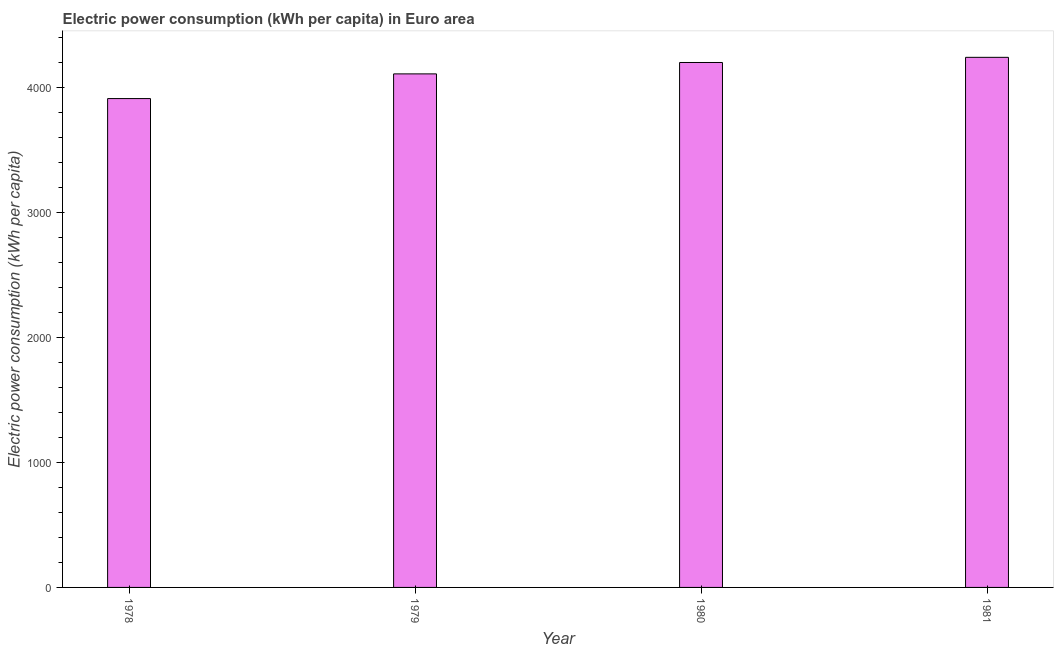Does the graph contain any zero values?
Give a very brief answer. No. Does the graph contain grids?
Give a very brief answer. No. What is the title of the graph?
Your answer should be compact. Electric power consumption (kWh per capita) in Euro area. What is the label or title of the Y-axis?
Give a very brief answer. Electric power consumption (kWh per capita). What is the electric power consumption in 1980?
Offer a very short reply. 4201.19. Across all years, what is the maximum electric power consumption?
Keep it short and to the point. 4242.56. Across all years, what is the minimum electric power consumption?
Offer a terse response. 3912.47. In which year was the electric power consumption minimum?
Make the answer very short. 1978. What is the sum of the electric power consumption?
Your answer should be compact. 1.65e+04. What is the difference between the electric power consumption in 1978 and 1981?
Offer a terse response. -330.09. What is the average electric power consumption per year?
Offer a very short reply. 4116.57. What is the median electric power consumption?
Provide a succinct answer. 4155.62. In how many years, is the electric power consumption greater than 2000 kWh per capita?
Offer a very short reply. 4. Do a majority of the years between 1978 and 1981 (inclusive) have electric power consumption greater than 800 kWh per capita?
Your answer should be very brief. Yes. Is the electric power consumption in 1978 less than that in 1980?
Give a very brief answer. Yes. What is the difference between the highest and the second highest electric power consumption?
Offer a very short reply. 41.37. What is the difference between the highest and the lowest electric power consumption?
Provide a short and direct response. 330.09. In how many years, is the electric power consumption greater than the average electric power consumption taken over all years?
Provide a short and direct response. 2. How many bars are there?
Provide a short and direct response. 4. Are all the bars in the graph horizontal?
Offer a very short reply. No. How many years are there in the graph?
Make the answer very short. 4. Are the values on the major ticks of Y-axis written in scientific E-notation?
Keep it short and to the point. No. What is the Electric power consumption (kWh per capita) of 1978?
Make the answer very short. 3912.47. What is the Electric power consumption (kWh per capita) of 1979?
Your answer should be very brief. 4110.05. What is the Electric power consumption (kWh per capita) in 1980?
Your answer should be compact. 4201.19. What is the Electric power consumption (kWh per capita) of 1981?
Ensure brevity in your answer.  4242.56. What is the difference between the Electric power consumption (kWh per capita) in 1978 and 1979?
Your response must be concise. -197.58. What is the difference between the Electric power consumption (kWh per capita) in 1978 and 1980?
Your answer should be very brief. -288.72. What is the difference between the Electric power consumption (kWh per capita) in 1978 and 1981?
Make the answer very short. -330.09. What is the difference between the Electric power consumption (kWh per capita) in 1979 and 1980?
Your answer should be compact. -91.14. What is the difference between the Electric power consumption (kWh per capita) in 1979 and 1981?
Keep it short and to the point. -132.51. What is the difference between the Electric power consumption (kWh per capita) in 1980 and 1981?
Your answer should be very brief. -41.37. What is the ratio of the Electric power consumption (kWh per capita) in 1978 to that in 1979?
Offer a terse response. 0.95. What is the ratio of the Electric power consumption (kWh per capita) in 1978 to that in 1981?
Ensure brevity in your answer.  0.92. What is the ratio of the Electric power consumption (kWh per capita) in 1979 to that in 1981?
Your answer should be compact. 0.97. What is the ratio of the Electric power consumption (kWh per capita) in 1980 to that in 1981?
Your answer should be very brief. 0.99. 